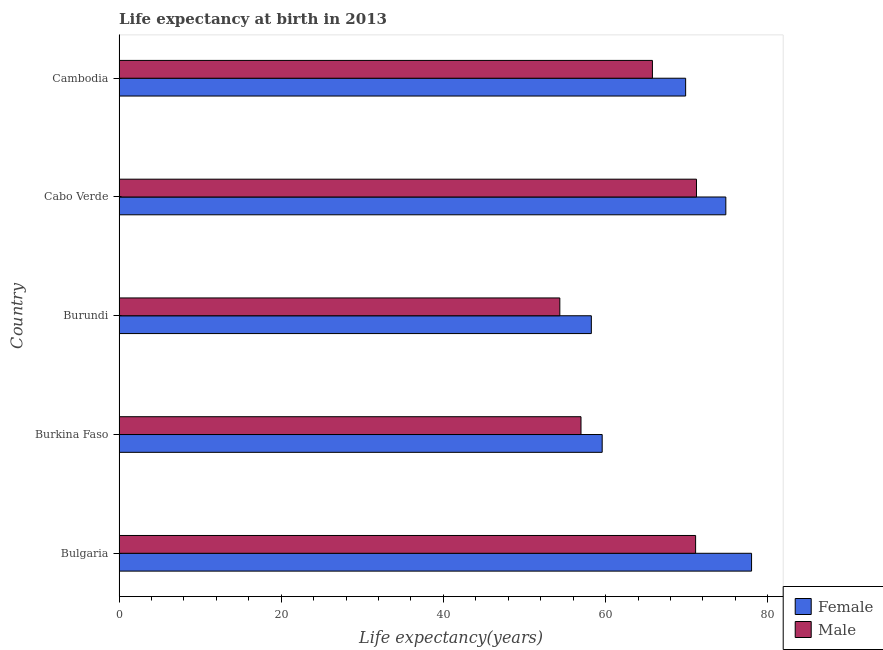How many different coloured bars are there?
Keep it short and to the point. 2. Are the number of bars per tick equal to the number of legend labels?
Your answer should be compact. Yes. What is the label of the 3rd group of bars from the top?
Offer a terse response. Burundi. In how many cases, is the number of bars for a given country not equal to the number of legend labels?
Your answer should be compact. 0. What is the life expectancy(male) in Burundi?
Offer a very short reply. 54.36. Across all countries, what is the maximum life expectancy(male)?
Provide a succinct answer. 71.21. Across all countries, what is the minimum life expectancy(male)?
Your answer should be very brief. 54.36. In which country was the life expectancy(female) minimum?
Your answer should be compact. Burundi. What is the total life expectancy(male) in the graph?
Ensure brevity in your answer.  319.4. What is the difference between the life expectancy(male) in Burundi and that in Cambodia?
Provide a succinct answer. -11.42. What is the difference between the life expectancy(male) in Bulgaria and the life expectancy(female) in Cabo Verde?
Provide a short and direct response. -3.73. What is the average life expectancy(female) per country?
Your response must be concise. 68.1. What is the difference between the life expectancy(male) and life expectancy(female) in Burundi?
Offer a very short reply. -3.89. In how many countries, is the life expectancy(female) greater than 28 years?
Your response must be concise. 5. What is the ratio of the life expectancy(female) in Bulgaria to that in Burundi?
Keep it short and to the point. 1.34. Is the life expectancy(male) in Burkina Faso less than that in Cambodia?
Provide a succinct answer. Yes. Is the difference between the life expectancy(male) in Burkina Faso and Cabo Verde greater than the difference between the life expectancy(female) in Burkina Faso and Cabo Verde?
Provide a succinct answer. Yes. What is the difference between the highest and the second highest life expectancy(male)?
Make the answer very short. 0.11. What is the difference between the highest and the lowest life expectancy(female)?
Provide a succinct answer. 19.76. What is the title of the graph?
Your answer should be very brief. Life expectancy at birth in 2013. Does "Passenger Transport Items" appear as one of the legend labels in the graph?
Your response must be concise. No. What is the label or title of the X-axis?
Your answer should be compact. Life expectancy(years). What is the Life expectancy(years) of Male in Bulgaria?
Your answer should be very brief. 71.1. What is the Life expectancy(years) in Female in Burkina Faso?
Provide a short and direct response. 59.58. What is the Life expectancy(years) in Male in Burkina Faso?
Your answer should be very brief. 56.97. What is the Life expectancy(years) of Female in Burundi?
Ensure brevity in your answer.  58.24. What is the Life expectancy(years) of Male in Burundi?
Offer a very short reply. 54.36. What is the Life expectancy(years) of Female in Cabo Verde?
Your response must be concise. 74.83. What is the Life expectancy(years) in Male in Cabo Verde?
Make the answer very short. 71.21. What is the Life expectancy(years) of Female in Cambodia?
Your response must be concise. 69.87. What is the Life expectancy(years) in Male in Cambodia?
Provide a short and direct response. 65.77. Across all countries, what is the maximum Life expectancy(years) of Female?
Your answer should be very brief. 78. Across all countries, what is the maximum Life expectancy(years) of Male?
Offer a very short reply. 71.21. Across all countries, what is the minimum Life expectancy(years) in Female?
Offer a very short reply. 58.24. Across all countries, what is the minimum Life expectancy(years) of Male?
Offer a very short reply. 54.36. What is the total Life expectancy(years) of Female in the graph?
Offer a terse response. 340.52. What is the total Life expectancy(years) in Male in the graph?
Provide a succinct answer. 319.4. What is the difference between the Life expectancy(years) of Female in Bulgaria and that in Burkina Faso?
Make the answer very short. 18.42. What is the difference between the Life expectancy(years) of Male in Bulgaria and that in Burkina Faso?
Your answer should be very brief. 14.13. What is the difference between the Life expectancy(years) in Female in Bulgaria and that in Burundi?
Offer a terse response. 19.76. What is the difference between the Life expectancy(years) in Male in Bulgaria and that in Burundi?
Keep it short and to the point. 16.74. What is the difference between the Life expectancy(years) of Female in Bulgaria and that in Cabo Verde?
Ensure brevity in your answer.  3.17. What is the difference between the Life expectancy(years) in Male in Bulgaria and that in Cabo Verde?
Your response must be concise. -0.11. What is the difference between the Life expectancy(years) in Female in Bulgaria and that in Cambodia?
Give a very brief answer. 8.13. What is the difference between the Life expectancy(years) of Male in Bulgaria and that in Cambodia?
Your answer should be very brief. 5.33. What is the difference between the Life expectancy(years) of Female in Burkina Faso and that in Burundi?
Provide a short and direct response. 1.34. What is the difference between the Life expectancy(years) in Male in Burkina Faso and that in Burundi?
Offer a terse response. 2.61. What is the difference between the Life expectancy(years) of Female in Burkina Faso and that in Cabo Verde?
Your response must be concise. -15.25. What is the difference between the Life expectancy(years) in Male in Burkina Faso and that in Cabo Verde?
Offer a terse response. -14.24. What is the difference between the Life expectancy(years) in Female in Burkina Faso and that in Cambodia?
Your answer should be very brief. -10.29. What is the difference between the Life expectancy(years) in Male in Burkina Faso and that in Cambodia?
Offer a very short reply. -8.81. What is the difference between the Life expectancy(years) in Female in Burundi and that in Cabo Verde?
Ensure brevity in your answer.  -16.58. What is the difference between the Life expectancy(years) of Male in Burundi and that in Cabo Verde?
Make the answer very short. -16.85. What is the difference between the Life expectancy(years) of Female in Burundi and that in Cambodia?
Your response must be concise. -11.63. What is the difference between the Life expectancy(years) of Male in Burundi and that in Cambodia?
Keep it short and to the point. -11.42. What is the difference between the Life expectancy(years) of Female in Cabo Verde and that in Cambodia?
Keep it short and to the point. 4.96. What is the difference between the Life expectancy(years) in Male in Cabo Verde and that in Cambodia?
Your answer should be compact. 5.43. What is the difference between the Life expectancy(years) in Female in Bulgaria and the Life expectancy(years) in Male in Burkina Faso?
Ensure brevity in your answer.  21.03. What is the difference between the Life expectancy(years) in Female in Bulgaria and the Life expectancy(years) in Male in Burundi?
Your response must be concise. 23.64. What is the difference between the Life expectancy(years) of Female in Bulgaria and the Life expectancy(years) of Male in Cabo Verde?
Give a very brief answer. 6.79. What is the difference between the Life expectancy(years) of Female in Bulgaria and the Life expectancy(years) of Male in Cambodia?
Make the answer very short. 12.23. What is the difference between the Life expectancy(years) of Female in Burkina Faso and the Life expectancy(years) of Male in Burundi?
Give a very brief answer. 5.22. What is the difference between the Life expectancy(years) of Female in Burkina Faso and the Life expectancy(years) of Male in Cabo Verde?
Make the answer very short. -11.63. What is the difference between the Life expectancy(years) of Female in Burkina Faso and the Life expectancy(years) of Male in Cambodia?
Offer a very short reply. -6.2. What is the difference between the Life expectancy(years) of Female in Burundi and the Life expectancy(years) of Male in Cabo Verde?
Keep it short and to the point. -12.96. What is the difference between the Life expectancy(years) in Female in Burundi and the Life expectancy(years) in Male in Cambodia?
Provide a short and direct response. -7.53. What is the difference between the Life expectancy(years) of Female in Cabo Verde and the Life expectancy(years) of Male in Cambodia?
Ensure brevity in your answer.  9.05. What is the average Life expectancy(years) of Female per country?
Your response must be concise. 68.1. What is the average Life expectancy(years) of Male per country?
Your answer should be very brief. 63.88. What is the difference between the Life expectancy(years) of Female and Life expectancy(years) of Male in Bulgaria?
Provide a succinct answer. 6.9. What is the difference between the Life expectancy(years) in Female and Life expectancy(years) in Male in Burkina Faso?
Your answer should be very brief. 2.61. What is the difference between the Life expectancy(years) in Female and Life expectancy(years) in Male in Burundi?
Provide a succinct answer. 3.89. What is the difference between the Life expectancy(years) of Female and Life expectancy(years) of Male in Cabo Verde?
Offer a terse response. 3.62. What is the difference between the Life expectancy(years) in Female and Life expectancy(years) in Male in Cambodia?
Your answer should be compact. 4.1. What is the ratio of the Life expectancy(years) of Female in Bulgaria to that in Burkina Faso?
Offer a terse response. 1.31. What is the ratio of the Life expectancy(years) of Male in Bulgaria to that in Burkina Faso?
Your answer should be compact. 1.25. What is the ratio of the Life expectancy(years) in Female in Bulgaria to that in Burundi?
Offer a very short reply. 1.34. What is the ratio of the Life expectancy(years) in Male in Bulgaria to that in Burundi?
Offer a very short reply. 1.31. What is the ratio of the Life expectancy(years) of Female in Bulgaria to that in Cabo Verde?
Your answer should be compact. 1.04. What is the ratio of the Life expectancy(years) in Female in Bulgaria to that in Cambodia?
Your answer should be compact. 1.12. What is the ratio of the Life expectancy(years) in Male in Bulgaria to that in Cambodia?
Keep it short and to the point. 1.08. What is the ratio of the Life expectancy(years) of Female in Burkina Faso to that in Burundi?
Ensure brevity in your answer.  1.02. What is the ratio of the Life expectancy(years) of Male in Burkina Faso to that in Burundi?
Your answer should be compact. 1.05. What is the ratio of the Life expectancy(years) of Female in Burkina Faso to that in Cabo Verde?
Ensure brevity in your answer.  0.8. What is the ratio of the Life expectancy(years) of Male in Burkina Faso to that in Cabo Verde?
Provide a short and direct response. 0.8. What is the ratio of the Life expectancy(years) of Female in Burkina Faso to that in Cambodia?
Offer a very short reply. 0.85. What is the ratio of the Life expectancy(years) of Male in Burkina Faso to that in Cambodia?
Offer a very short reply. 0.87. What is the ratio of the Life expectancy(years) of Female in Burundi to that in Cabo Verde?
Ensure brevity in your answer.  0.78. What is the ratio of the Life expectancy(years) in Male in Burundi to that in Cabo Verde?
Your answer should be compact. 0.76. What is the ratio of the Life expectancy(years) of Female in Burundi to that in Cambodia?
Provide a short and direct response. 0.83. What is the ratio of the Life expectancy(years) in Male in Burundi to that in Cambodia?
Make the answer very short. 0.83. What is the ratio of the Life expectancy(years) in Female in Cabo Verde to that in Cambodia?
Offer a very short reply. 1.07. What is the ratio of the Life expectancy(years) of Male in Cabo Verde to that in Cambodia?
Keep it short and to the point. 1.08. What is the difference between the highest and the second highest Life expectancy(years) of Female?
Provide a succinct answer. 3.17. What is the difference between the highest and the second highest Life expectancy(years) in Male?
Ensure brevity in your answer.  0.11. What is the difference between the highest and the lowest Life expectancy(years) of Female?
Your answer should be very brief. 19.76. What is the difference between the highest and the lowest Life expectancy(years) of Male?
Offer a terse response. 16.85. 